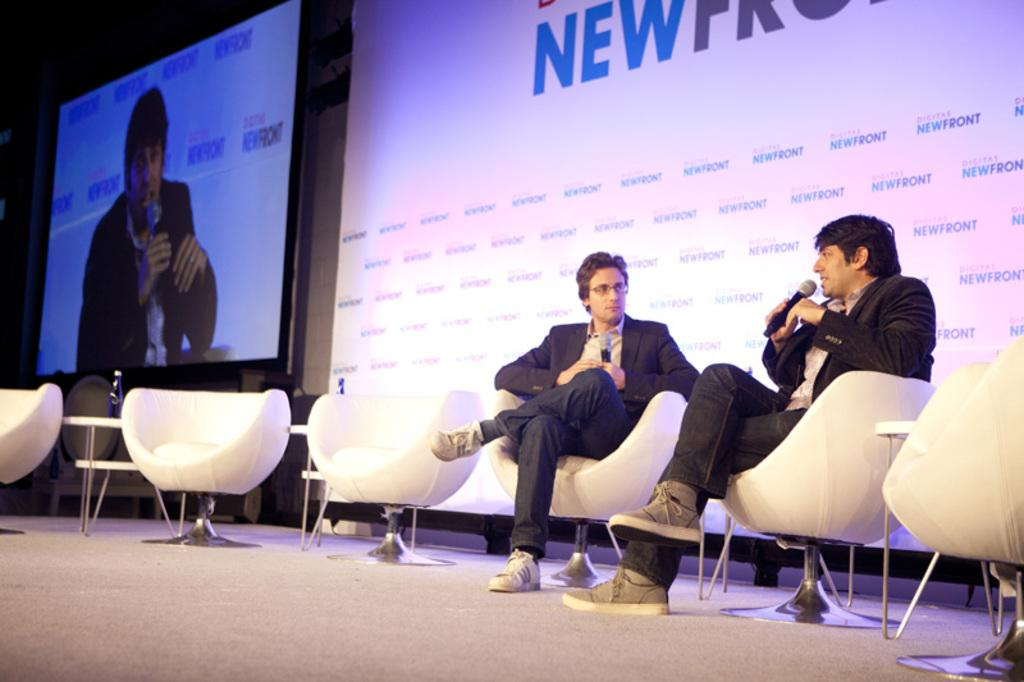What is the main object in the image? There is a screen in the image. What else can be seen in the image besides the screen? There is a banner in the image. How many people are present in the image? There are two people sitting on chairs in the image. What are the two people holding? The two people are holding mics. What type of lettuce is visible on the screen in the image? There is no lettuce visible on the screen in the image. 